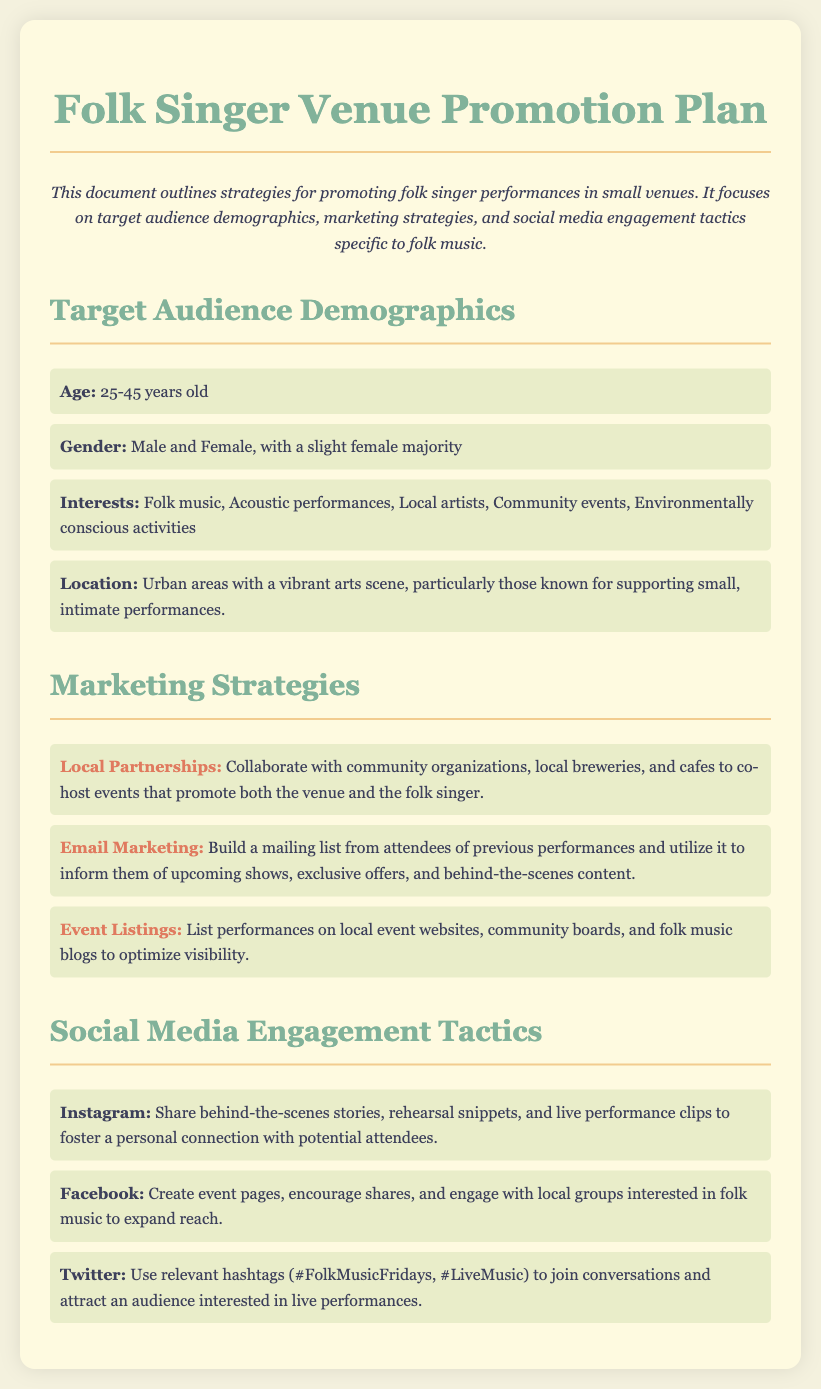What is the age range of the target audience? The age range specifies the demographic that is interested in folk singer performances, which is listed as 25-45 years old.
Answer: 25-45 years old What gender has a slight majority in the target audience? The gender demographic outlines the composition of the audience, indicating a slight female majority.
Answer: Female What strategy involves collaborating with local businesses? The document mentions working with community organizations and local venues to promote performances, identified as Local Partnerships.
Answer: Local Partnerships Which social media platform encourages sharing event pages? The document specifies that Facebook is the platform for creating event pages and encouraging shares to engage the audience.
Answer: Facebook What interests are associated with the target audience? The document lists interests related to the audience, highlighting their connection to folk music and community events.
Answer: Folk music, Acoustic performances, Local artists, Community events, Environmentally conscious activities How many marketing strategies are provided in the document? The document includes a list of marketing strategies that are outlined, which are three in total.
Answer: Three What is one tactic for engaging audiences on Instagram? The document states that sharing behind-the-scenes stories is a tactic to engage potential attendees on Instagram.
Answer: Behind-the-scenes stories Which hashtag is suggested for Twitter engagement? The document lists relevant hashtags to attract an audience for live performances on Twitter, specifically mentioning #FolkMusicFridays.
Answer: #FolkMusicFridays What is the primary focus of the document? The document outlines strategies specifically aimed at promoting folk singer performances in small venues.
Answer: Promoting folk singer performances in small venues 